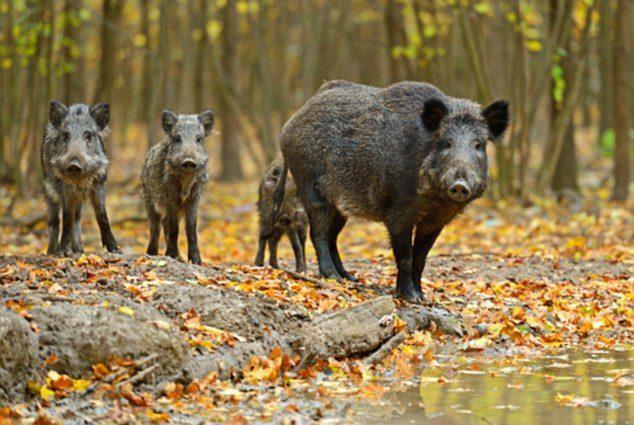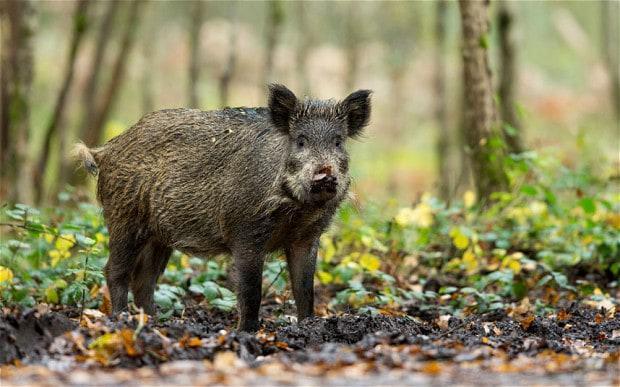The first image is the image on the left, the second image is the image on the right. Evaluate the accuracy of this statement regarding the images: "A pig is on its side.". Is it true? Answer yes or no. No. The first image is the image on the left, the second image is the image on the right. For the images shown, is this caption "There is at least one person in one of the photos." true? Answer yes or no. No. 